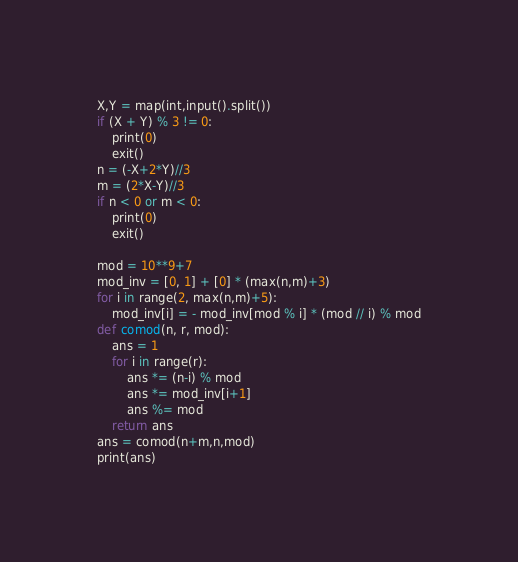<code> <loc_0><loc_0><loc_500><loc_500><_Python_>X,Y = map(int,input().split())
if (X + Y) % 3 != 0:
    print(0)
    exit()
n = (-X+2*Y)//3
m = (2*X-Y)//3
if n < 0 or m < 0:
    print(0)
    exit()

mod = 10**9+7
mod_inv = [0, 1] + [0] * (max(n,m)+3)
for i in range(2, max(n,m)+5):
    mod_inv[i] = - mod_inv[mod % i] * (mod // i) % mod
def comod(n, r, mod):
    ans = 1
    for i in range(r):
        ans *= (n-i) % mod
        ans *= mod_inv[i+1]
        ans %= mod
    return ans
ans = comod(n+m,n,mod)
print(ans)</code> 